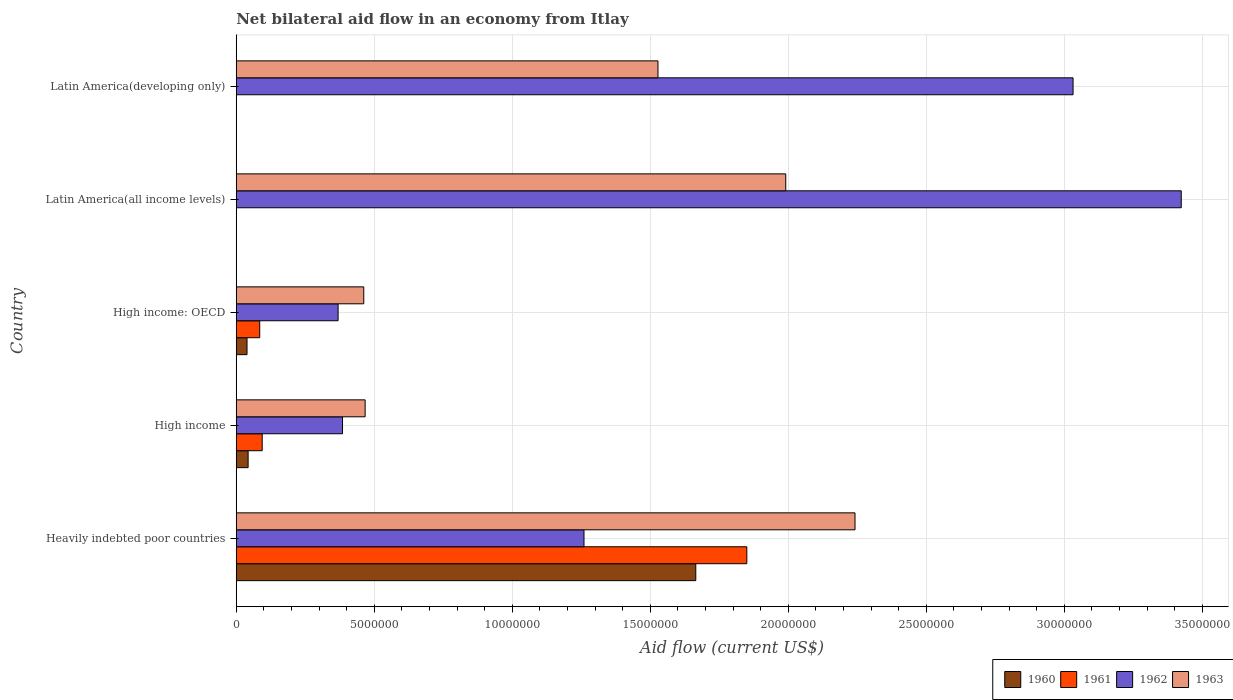How many groups of bars are there?
Your answer should be compact. 5. How many bars are there on the 5th tick from the top?
Ensure brevity in your answer.  4. How many bars are there on the 5th tick from the bottom?
Offer a terse response. 2. What is the label of the 4th group of bars from the top?
Your answer should be compact. High income. What is the net bilateral aid flow in 1963 in High income?
Your answer should be very brief. 4.67e+06. Across all countries, what is the maximum net bilateral aid flow in 1962?
Offer a terse response. 3.42e+07. Across all countries, what is the minimum net bilateral aid flow in 1962?
Keep it short and to the point. 3.69e+06. In which country was the net bilateral aid flow in 1960 maximum?
Your answer should be very brief. Heavily indebted poor countries. What is the total net bilateral aid flow in 1961 in the graph?
Give a very brief answer. 2.03e+07. What is the difference between the net bilateral aid flow in 1963 in Latin America(all income levels) and that in Latin America(developing only)?
Give a very brief answer. 4.63e+06. What is the difference between the net bilateral aid flow in 1962 in Latin America(developing only) and the net bilateral aid flow in 1961 in High income: OECD?
Your response must be concise. 2.95e+07. What is the average net bilateral aid flow in 1961 per country?
Ensure brevity in your answer.  4.06e+06. What is the difference between the net bilateral aid flow in 1961 and net bilateral aid flow in 1963 in High income: OECD?
Make the answer very short. -3.77e+06. In how many countries, is the net bilateral aid flow in 1963 greater than 1000000 US$?
Provide a short and direct response. 5. What is the ratio of the net bilateral aid flow in 1960 in Heavily indebted poor countries to that in High income: OECD?
Your answer should be compact. 42.69. Is the net bilateral aid flow in 1961 in Heavily indebted poor countries less than that in High income: OECD?
Your answer should be compact. No. What is the difference between the highest and the second highest net bilateral aid flow in 1963?
Your response must be concise. 2.51e+06. What is the difference between the highest and the lowest net bilateral aid flow in 1963?
Offer a very short reply. 1.78e+07. In how many countries, is the net bilateral aid flow in 1961 greater than the average net bilateral aid flow in 1961 taken over all countries?
Your answer should be very brief. 1. Is it the case that in every country, the sum of the net bilateral aid flow in 1962 and net bilateral aid flow in 1961 is greater than the sum of net bilateral aid flow in 1960 and net bilateral aid flow in 1963?
Keep it short and to the point. No. How many bars are there?
Provide a succinct answer. 16. Are all the bars in the graph horizontal?
Your answer should be very brief. Yes. How many countries are there in the graph?
Offer a terse response. 5. What is the difference between two consecutive major ticks on the X-axis?
Keep it short and to the point. 5.00e+06. Are the values on the major ticks of X-axis written in scientific E-notation?
Make the answer very short. No. Where does the legend appear in the graph?
Ensure brevity in your answer.  Bottom right. How many legend labels are there?
Ensure brevity in your answer.  4. What is the title of the graph?
Your answer should be very brief. Net bilateral aid flow in an economy from Itlay. Does "1976" appear as one of the legend labels in the graph?
Offer a very short reply. No. What is the label or title of the X-axis?
Offer a very short reply. Aid flow (current US$). What is the Aid flow (current US$) in 1960 in Heavily indebted poor countries?
Provide a short and direct response. 1.66e+07. What is the Aid flow (current US$) of 1961 in Heavily indebted poor countries?
Your response must be concise. 1.85e+07. What is the Aid flow (current US$) of 1962 in Heavily indebted poor countries?
Your answer should be very brief. 1.26e+07. What is the Aid flow (current US$) in 1963 in Heavily indebted poor countries?
Make the answer very short. 2.24e+07. What is the Aid flow (current US$) of 1961 in High income?
Provide a short and direct response. 9.40e+05. What is the Aid flow (current US$) in 1962 in High income?
Offer a very short reply. 3.85e+06. What is the Aid flow (current US$) in 1963 in High income?
Offer a terse response. 4.67e+06. What is the Aid flow (current US$) of 1960 in High income: OECD?
Offer a very short reply. 3.90e+05. What is the Aid flow (current US$) of 1961 in High income: OECD?
Your answer should be very brief. 8.50e+05. What is the Aid flow (current US$) in 1962 in High income: OECD?
Your response must be concise. 3.69e+06. What is the Aid flow (current US$) in 1963 in High income: OECD?
Ensure brevity in your answer.  4.62e+06. What is the Aid flow (current US$) in 1960 in Latin America(all income levels)?
Your response must be concise. 0. What is the Aid flow (current US$) of 1961 in Latin America(all income levels)?
Make the answer very short. 0. What is the Aid flow (current US$) of 1962 in Latin America(all income levels)?
Keep it short and to the point. 3.42e+07. What is the Aid flow (current US$) of 1963 in Latin America(all income levels)?
Your answer should be compact. 1.99e+07. What is the Aid flow (current US$) in 1961 in Latin America(developing only)?
Offer a very short reply. 0. What is the Aid flow (current US$) of 1962 in Latin America(developing only)?
Offer a terse response. 3.03e+07. What is the Aid flow (current US$) in 1963 in Latin America(developing only)?
Make the answer very short. 1.53e+07. Across all countries, what is the maximum Aid flow (current US$) of 1960?
Give a very brief answer. 1.66e+07. Across all countries, what is the maximum Aid flow (current US$) in 1961?
Offer a very short reply. 1.85e+07. Across all countries, what is the maximum Aid flow (current US$) in 1962?
Provide a short and direct response. 3.42e+07. Across all countries, what is the maximum Aid flow (current US$) in 1963?
Offer a very short reply. 2.24e+07. Across all countries, what is the minimum Aid flow (current US$) of 1960?
Provide a succinct answer. 0. Across all countries, what is the minimum Aid flow (current US$) of 1961?
Offer a very short reply. 0. Across all countries, what is the minimum Aid flow (current US$) in 1962?
Your response must be concise. 3.69e+06. Across all countries, what is the minimum Aid flow (current US$) of 1963?
Offer a terse response. 4.62e+06. What is the total Aid flow (current US$) of 1960 in the graph?
Provide a short and direct response. 1.75e+07. What is the total Aid flow (current US$) in 1961 in the graph?
Your response must be concise. 2.03e+07. What is the total Aid flow (current US$) in 1962 in the graph?
Keep it short and to the point. 8.47e+07. What is the total Aid flow (current US$) of 1963 in the graph?
Offer a terse response. 6.69e+07. What is the difference between the Aid flow (current US$) of 1960 in Heavily indebted poor countries and that in High income?
Your response must be concise. 1.62e+07. What is the difference between the Aid flow (current US$) in 1961 in Heavily indebted poor countries and that in High income?
Ensure brevity in your answer.  1.76e+07. What is the difference between the Aid flow (current US$) in 1962 in Heavily indebted poor countries and that in High income?
Provide a succinct answer. 8.75e+06. What is the difference between the Aid flow (current US$) of 1963 in Heavily indebted poor countries and that in High income?
Give a very brief answer. 1.78e+07. What is the difference between the Aid flow (current US$) of 1960 in Heavily indebted poor countries and that in High income: OECD?
Your answer should be very brief. 1.63e+07. What is the difference between the Aid flow (current US$) in 1961 in Heavily indebted poor countries and that in High income: OECD?
Offer a very short reply. 1.76e+07. What is the difference between the Aid flow (current US$) of 1962 in Heavily indebted poor countries and that in High income: OECD?
Keep it short and to the point. 8.91e+06. What is the difference between the Aid flow (current US$) in 1963 in Heavily indebted poor countries and that in High income: OECD?
Give a very brief answer. 1.78e+07. What is the difference between the Aid flow (current US$) in 1962 in Heavily indebted poor countries and that in Latin America(all income levels)?
Keep it short and to the point. -2.16e+07. What is the difference between the Aid flow (current US$) of 1963 in Heavily indebted poor countries and that in Latin America(all income levels)?
Your answer should be very brief. 2.51e+06. What is the difference between the Aid flow (current US$) of 1962 in Heavily indebted poor countries and that in Latin America(developing only)?
Provide a short and direct response. -1.77e+07. What is the difference between the Aid flow (current US$) of 1963 in Heavily indebted poor countries and that in Latin America(developing only)?
Keep it short and to the point. 7.14e+06. What is the difference between the Aid flow (current US$) in 1961 in High income and that in High income: OECD?
Provide a succinct answer. 9.00e+04. What is the difference between the Aid flow (current US$) in 1962 in High income and that in High income: OECD?
Provide a succinct answer. 1.60e+05. What is the difference between the Aid flow (current US$) in 1962 in High income and that in Latin America(all income levels)?
Ensure brevity in your answer.  -3.04e+07. What is the difference between the Aid flow (current US$) of 1963 in High income and that in Latin America(all income levels)?
Provide a short and direct response. -1.52e+07. What is the difference between the Aid flow (current US$) in 1962 in High income and that in Latin America(developing only)?
Your response must be concise. -2.65e+07. What is the difference between the Aid flow (current US$) in 1963 in High income and that in Latin America(developing only)?
Your answer should be very brief. -1.06e+07. What is the difference between the Aid flow (current US$) in 1962 in High income: OECD and that in Latin America(all income levels)?
Your answer should be compact. -3.06e+07. What is the difference between the Aid flow (current US$) of 1963 in High income: OECD and that in Latin America(all income levels)?
Give a very brief answer. -1.53e+07. What is the difference between the Aid flow (current US$) of 1962 in High income: OECD and that in Latin America(developing only)?
Your response must be concise. -2.66e+07. What is the difference between the Aid flow (current US$) of 1963 in High income: OECD and that in Latin America(developing only)?
Ensure brevity in your answer.  -1.07e+07. What is the difference between the Aid flow (current US$) in 1962 in Latin America(all income levels) and that in Latin America(developing only)?
Offer a very short reply. 3.92e+06. What is the difference between the Aid flow (current US$) in 1963 in Latin America(all income levels) and that in Latin America(developing only)?
Provide a succinct answer. 4.63e+06. What is the difference between the Aid flow (current US$) of 1960 in Heavily indebted poor countries and the Aid flow (current US$) of 1961 in High income?
Your response must be concise. 1.57e+07. What is the difference between the Aid flow (current US$) of 1960 in Heavily indebted poor countries and the Aid flow (current US$) of 1962 in High income?
Provide a succinct answer. 1.28e+07. What is the difference between the Aid flow (current US$) in 1960 in Heavily indebted poor countries and the Aid flow (current US$) in 1963 in High income?
Give a very brief answer. 1.20e+07. What is the difference between the Aid flow (current US$) of 1961 in Heavily indebted poor countries and the Aid flow (current US$) of 1962 in High income?
Offer a terse response. 1.46e+07. What is the difference between the Aid flow (current US$) of 1961 in Heavily indebted poor countries and the Aid flow (current US$) of 1963 in High income?
Your answer should be very brief. 1.38e+07. What is the difference between the Aid flow (current US$) of 1962 in Heavily indebted poor countries and the Aid flow (current US$) of 1963 in High income?
Your answer should be very brief. 7.93e+06. What is the difference between the Aid flow (current US$) of 1960 in Heavily indebted poor countries and the Aid flow (current US$) of 1961 in High income: OECD?
Give a very brief answer. 1.58e+07. What is the difference between the Aid flow (current US$) of 1960 in Heavily indebted poor countries and the Aid flow (current US$) of 1962 in High income: OECD?
Make the answer very short. 1.30e+07. What is the difference between the Aid flow (current US$) of 1960 in Heavily indebted poor countries and the Aid flow (current US$) of 1963 in High income: OECD?
Offer a terse response. 1.20e+07. What is the difference between the Aid flow (current US$) of 1961 in Heavily indebted poor countries and the Aid flow (current US$) of 1962 in High income: OECD?
Your response must be concise. 1.48e+07. What is the difference between the Aid flow (current US$) of 1961 in Heavily indebted poor countries and the Aid flow (current US$) of 1963 in High income: OECD?
Provide a succinct answer. 1.39e+07. What is the difference between the Aid flow (current US$) of 1962 in Heavily indebted poor countries and the Aid flow (current US$) of 1963 in High income: OECD?
Provide a short and direct response. 7.98e+06. What is the difference between the Aid flow (current US$) of 1960 in Heavily indebted poor countries and the Aid flow (current US$) of 1962 in Latin America(all income levels)?
Your answer should be compact. -1.76e+07. What is the difference between the Aid flow (current US$) in 1960 in Heavily indebted poor countries and the Aid flow (current US$) in 1963 in Latin America(all income levels)?
Offer a terse response. -3.26e+06. What is the difference between the Aid flow (current US$) of 1961 in Heavily indebted poor countries and the Aid flow (current US$) of 1962 in Latin America(all income levels)?
Give a very brief answer. -1.57e+07. What is the difference between the Aid flow (current US$) of 1961 in Heavily indebted poor countries and the Aid flow (current US$) of 1963 in Latin America(all income levels)?
Ensure brevity in your answer.  -1.41e+06. What is the difference between the Aid flow (current US$) in 1962 in Heavily indebted poor countries and the Aid flow (current US$) in 1963 in Latin America(all income levels)?
Your answer should be compact. -7.31e+06. What is the difference between the Aid flow (current US$) of 1960 in Heavily indebted poor countries and the Aid flow (current US$) of 1962 in Latin America(developing only)?
Offer a terse response. -1.37e+07. What is the difference between the Aid flow (current US$) of 1960 in Heavily indebted poor countries and the Aid flow (current US$) of 1963 in Latin America(developing only)?
Your answer should be very brief. 1.37e+06. What is the difference between the Aid flow (current US$) of 1961 in Heavily indebted poor countries and the Aid flow (current US$) of 1962 in Latin America(developing only)?
Make the answer very short. -1.18e+07. What is the difference between the Aid flow (current US$) in 1961 in Heavily indebted poor countries and the Aid flow (current US$) in 1963 in Latin America(developing only)?
Offer a very short reply. 3.22e+06. What is the difference between the Aid flow (current US$) in 1962 in Heavily indebted poor countries and the Aid flow (current US$) in 1963 in Latin America(developing only)?
Offer a very short reply. -2.68e+06. What is the difference between the Aid flow (current US$) in 1960 in High income and the Aid flow (current US$) in 1961 in High income: OECD?
Keep it short and to the point. -4.20e+05. What is the difference between the Aid flow (current US$) in 1960 in High income and the Aid flow (current US$) in 1962 in High income: OECD?
Offer a terse response. -3.26e+06. What is the difference between the Aid flow (current US$) of 1960 in High income and the Aid flow (current US$) of 1963 in High income: OECD?
Your response must be concise. -4.19e+06. What is the difference between the Aid flow (current US$) of 1961 in High income and the Aid flow (current US$) of 1962 in High income: OECD?
Offer a very short reply. -2.75e+06. What is the difference between the Aid flow (current US$) in 1961 in High income and the Aid flow (current US$) in 1963 in High income: OECD?
Keep it short and to the point. -3.68e+06. What is the difference between the Aid flow (current US$) in 1962 in High income and the Aid flow (current US$) in 1963 in High income: OECD?
Your answer should be very brief. -7.70e+05. What is the difference between the Aid flow (current US$) of 1960 in High income and the Aid flow (current US$) of 1962 in Latin America(all income levels)?
Offer a terse response. -3.38e+07. What is the difference between the Aid flow (current US$) in 1960 in High income and the Aid flow (current US$) in 1963 in Latin America(all income levels)?
Give a very brief answer. -1.95e+07. What is the difference between the Aid flow (current US$) in 1961 in High income and the Aid flow (current US$) in 1962 in Latin America(all income levels)?
Provide a short and direct response. -3.33e+07. What is the difference between the Aid flow (current US$) of 1961 in High income and the Aid flow (current US$) of 1963 in Latin America(all income levels)?
Offer a very short reply. -1.90e+07. What is the difference between the Aid flow (current US$) of 1962 in High income and the Aid flow (current US$) of 1963 in Latin America(all income levels)?
Ensure brevity in your answer.  -1.61e+07. What is the difference between the Aid flow (current US$) of 1960 in High income and the Aid flow (current US$) of 1962 in Latin America(developing only)?
Keep it short and to the point. -2.99e+07. What is the difference between the Aid flow (current US$) of 1960 in High income and the Aid flow (current US$) of 1963 in Latin America(developing only)?
Provide a short and direct response. -1.48e+07. What is the difference between the Aid flow (current US$) of 1961 in High income and the Aid flow (current US$) of 1962 in Latin America(developing only)?
Provide a succinct answer. -2.94e+07. What is the difference between the Aid flow (current US$) of 1961 in High income and the Aid flow (current US$) of 1963 in Latin America(developing only)?
Provide a short and direct response. -1.43e+07. What is the difference between the Aid flow (current US$) of 1962 in High income and the Aid flow (current US$) of 1963 in Latin America(developing only)?
Offer a very short reply. -1.14e+07. What is the difference between the Aid flow (current US$) in 1960 in High income: OECD and the Aid flow (current US$) in 1962 in Latin America(all income levels)?
Ensure brevity in your answer.  -3.38e+07. What is the difference between the Aid flow (current US$) of 1960 in High income: OECD and the Aid flow (current US$) of 1963 in Latin America(all income levels)?
Give a very brief answer. -1.95e+07. What is the difference between the Aid flow (current US$) in 1961 in High income: OECD and the Aid flow (current US$) in 1962 in Latin America(all income levels)?
Make the answer very short. -3.34e+07. What is the difference between the Aid flow (current US$) of 1961 in High income: OECD and the Aid flow (current US$) of 1963 in Latin America(all income levels)?
Keep it short and to the point. -1.91e+07. What is the difference between the Aid flow (current US$) in 1962 in High income: OECD and the Aid flow (current US$) in 1963 in Latin America(all income levels)?
Your answer should be very brief. -1.62e+07. What is the difference between the Aid flow (current US$) of 1960 in High income: OECD and the Aid flow (current US$) of 1962 in Latin America(developing only)?
Your answer should be compact. -2.99e+07. What is the difference between the Aid flow (current US$) of 1960 in High income: OECD and the Aid flow (current US$) of 1963 in Latin America(developing only)?
Make the answer very short. -1.49e+07. What is the difference between the Aid flow (current US$) in 1961 in High income: OECD and the Aid flow (current US$) in 1962 in Latin America(developing only)?
Offer a terse response. -2.95e+07. What is the difference between the Aid flow (current US$) of 1961 in High income: OECD and the Aid flow (current US$) of 1963 in Latin America(developing only)?
Provide a short and direct response. -1.44e+07. What is the difference between the Aid flow (current US$) of 1962 in High income: OECD and the Aid flow (current US$) of 1963 in Latin America(developing only)?
Offer a very short reply. -1.16e+07. What is the difference between the Aid flow (current US$) in 1962 in Latin America(all income levels) and the Aid flow (current US$) in 1963 in Latin America(developing only)?
Provide a short and direct response. 1.90e+07. What is the average Aid flow (current US$) of 1960 per country?
Provide a short and direct response. 3.49e+06. What is the average Aid flow (current US$) of 1961 per country?
Provide a succinct answer. 4.06e+06. What is the average Aid flow (current US$) in 1962 per country?
Keep it short and to the point. 1.69e+07. What is the average Aid flow (current US$) in 1963 per country?
Ensure brevity in your answer.  1.34e+07. What is the difference between the Aid flow (current US$) in 1960 and Aid flow (current US$) in 1961 in Heavily indebted poor countries?
Offer a terse response. -1.85e+06. What is the difference between the Aid flow (current US$) in 1960 and Aid flow (current US$) in 1962 in Heavily indebted poor countries?
Provide a succinct answer. 4.05e+06. What is the difference between the Aid flow (current US$) in 1960 and Aid flow (current US$) in 1963 in Heavily indebted poor countries?
Provide a short and direct response. -5.77e+06. What is the difference between the Aid flow (current US$) in 1961 and Aid flow (current US$) in 1962 in Heavily indebted poor countries?
Give a very brief answer. 5.90e+06. What is the difference between the Aid flow (current US$) of 1961 and Aid flow (current US$) of 1963 in Heavily indebted poor countries?
Provide a short and direct response. -3.92e+06. What is the difference between the Aid flow (current US$) of 1962 and Aid flow (current US$) of 1963 in Heavily indebted poor countries?
Offer a very short reply. -9.82e+06. What is the difference between the Aid flow (current US$) of 1960 and Aid flow (current US$) of 1961 in High income?
Your answer should be very brief. -5.10e+05. What is the difference between the Aid flow (current US$) in 1960 and Aid flow (current US$) in 1962 in High income?
Ensure brevity in your answer.  -3.42e+06. What is the difference between the Aid flow (current US$) of 1960 and Aid flow (current US$) of 1963 in High income?
Give a very brief answer. -4.24e+06. What is the difference between the Aid flow (current US$) of 1961 and Aid flow (current US$) of 1962 in High income?
Offer a terse response. -2.91e+06. What is the difference between the Aid flow (current US$) in 1961 and Aid flow (current US$) in 1963 in High income?
Your answer should be compact. -3.73e+06. What is the difference between the Aid flow (current US$) of 1962 and Aid flow (current US$) of 1963 in High income?
Your answer should be very brief. -8.20e+05. What is the difference between the Aid flow (current US$) in 1960 and Aid flow (current US$) in 1961 in High income: OECD?
Ensure brevity in your answer.  -4.60e+05. What is the difference between the Aid flow (current US$) of 1960 and Aid flow (current US$) of 1962 in High income: OECD?
Offer a terse response. -3.30e+06. What is the difference between the Aid flow (current US$) of 1960 and Aid flow (current US$) of 1963 in High income: OECD?
Ensure brevity in your answer.  -4.23e+06. What is the difference between the Aid flow (current US$) of 1961 and Aid flow (current US$) of 1962 in High income: OECD?
Provide a short and direct response. -2.84e+06. What is the difference between the Aid flow (current US$) of 1961 and Aid flow (current US$) of 1963 in High income: OECD?
Provide a short and direct response. -3.77e+06. What is the difference between the Aid flow (current US$) of 1962 and Aid flow (current US$) of 1963 in High income: OECD?
Provide a short and direct response. -9.30e+05. What is the difference between the Aid flow (current US$) of 1962 and Aid flow (current US$) of 1963 in Latin America(all income levels)?
Ensure brevity in your answer.  1.43e+07. What is the difference between the Aid flow (current US$) in 1962 and Aid flow (current US$) in 1963 in Latin America(developing only)?
Make the answer very short. 1.50e+07. What is the ratio of the Aid flow (current US$) of 1960 in Heavily indebted poor countries to that in High income?
Offer a very short reply. 38.72. What is the ratio of the Aid flow (current US$) of 1961 in Heavily indebted poor countries to that in High income?
Offer a very short reply. 19.68. What is the ratio of the Aid flow (current US$) of 1962 in Heavily indebted poor countries to that in High income?
Provide a short and direct response. 3.27. What is the ratio of the Aid flow (current US$) in 1963 in Heavily indebted poor countries to that in High income?
Ensure brevity in your answer.  4.8. What is the ratio of the Aid flow (current US$) in 1960 in Heavily indebted poor countries to that in High income: OECD?
Offer a terse response. 42.69. What is the ratio of the Aid flow (current US$) of 1961 in Heavily indebted poor countries to that in High income: OECD?
Keep it short and to the point. 21.76. What is the ratio of the Aid flow (current US$) of 1962 in Heavily indebted poor countries to that in High income: OECD?
Provide a short and direct response. 3.41. What is the ratio of the Aid flow (current US$) in 1963 in Heavily indebted poor countries to that in High income: OECD?
Offer a terse response. 4.85. What is the ratio of the Aid flow (current US$) in 1962 in Heavily indebted poor countries to that in Latin America(all income levels)?
Your answer should be compact. 0.37. What is the ratio of the Aid flow (current US$) in 1963 in Heavily indebted poor countries to that in Latin America(all income levels)?
Your answer should be very brief. 1.13. What is the ratio of the Aid flow (current US$) in 1962 in Heavily indebted poor countries to that in Latin America(developing only)?
Offer a very short reply. 0.42. What is the ratio of the Aid flow (current US$) in 1963 in Heavily indebted poor countries to that in Latin America(developing only)?
Keep it short and to the point. 1.47. What is the ratio of the Aid flow (current US$) of 1960 in High income to that in High income: OECD?
Provide a succinct answer. 1.1. What is the ratio of the Aid flow (current US$) in 1961 in High income to that in High income: OECD?
Your answer should be compact. 1.11. What is the ratio of the Aid flow (current US$) of 1962 in High income to that in High income: OECD?
Provide a succinct answer. 1.04. What is the ratio of the Aid flow (current US$) in 1963 in High income to that in High income: OECD?
Keep it short and to the point. 1.01. What is the ratio of the Aid flow (current US$) in 1962 in High income to that in Latin America(all income levels)?
Provide a succinct answer. 0.11. What is the ratio of the Aid flow (current US$) in 1963 in High income to that in Latin America(all income levels)?
Your answer should be very brief. 0.23. What is the ratio of the Aid flow (current US$) of 1962 in High income to that in Latin America(developing only)?
Ensure brevity in your answer.  0.13. What is the ratio of the Aid flow (current US$) of 1963 in High income to that in Latin America(developing only)?
Your response must be concise. 0.31. What is the ratio of the Aid flow (current US$) of 1962 in High income: OECD to that in Latin America(all income levels)?
Your answer should be very brief. 0.11. What is the ratio of the Aid flow (current US$) of 1963 in High income: OECD to that in Latin America(all income levels)?
Keep it short and to the point. 0.23. What is the ratio of the Aid flow (current US$) in 1962 in High income: OECD to that in Latin America(developing only)?
Keep it short and to the point. 0.12. What is the ratio of the Aid flow (current US$) of 1963 in High income: OECD to that in Latin America(developing only)?
Your answer should be compact. 0.3. What is the ratio of the Aid flow (current US$) in 1962 in Latin America(all income levels) to that in Latin America(developing only)?
Your answer should be very brief. 1.13. What is the ratio of the Aid flow (current US$) in 1963 in Latin America(all income levels) to that in Latin America(developing only)?
Your answer should be compact. 1.3. What is the difference between the highest and the second highest Aid flow (current US$) in 1960?
Your response must be concise. 1.62e+07. What is the difference between the highest and the second highest Aid flow (current US$) of 1961?
Offer a terse response. 1.76e+07. What is the difference between the highest and the second highest Aid flow (current US$) in 1962?
Offer a very short reply. 3.92e+06. What is the difference between the highest and the second highest Aid flow (current US$) in 1963?
Ensure brevity in your answer.  2.51e+06. What is the difference between the highest and the lowest Aid flow (current US$) of 1960?
Offer a terse response. 1.66e+07. What is the difference between the highest and the lowest Aid flow (current US$) in 1961?
Give a very brief answer. 1.85e+07. What is the difference between the highest and the lowest Aid flow (current US$) in 1962?
Give a very brief answer. 3.06e+07. What is the difference between the highest and the lowest Aid flow (current US$) in 1963?
Offer a terse response. 1.78e+07. 